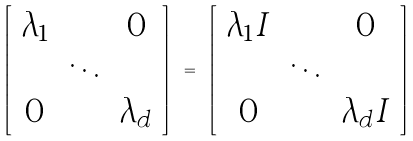Convert formula to latex. <formula><loc_0><loc_0><loc_500><loc_500>\left [ \begin{array} { c c c } \lambda _ { 1 } & & 0 \\ & \ddots & \\ 0 & & \lambda _ { d } \end{array} \right ] \ = \ \left [ \begin{array} { c c c } \lambda _ { 1 } I & & 0 \\ & \ddots & \\ 0 & & \lambda _ { d } I \end{array} \right ]</formula> 